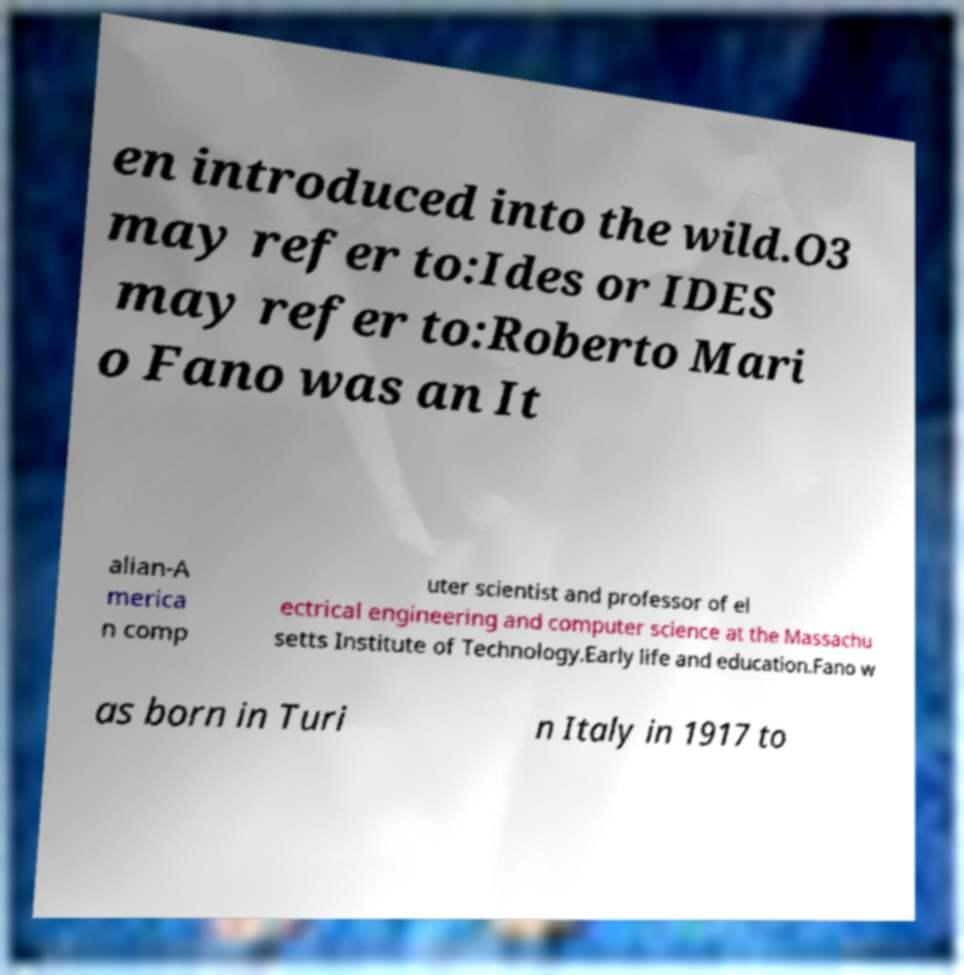Can you read and provide the text displayed in the image?This photo seems to have some interesting text. Can you extract and type it out for me? en introduced into the wild.O3 may refer to:Ides or IDES may refer to:Roberto Mari o Fano was an It alian-A merica n comp uter scientist and professor of el ectrical engineering and computer science at the Massachu setts Institute of Technology.Early life and education.Fano w as born in Turi n Italy in 1917 to 